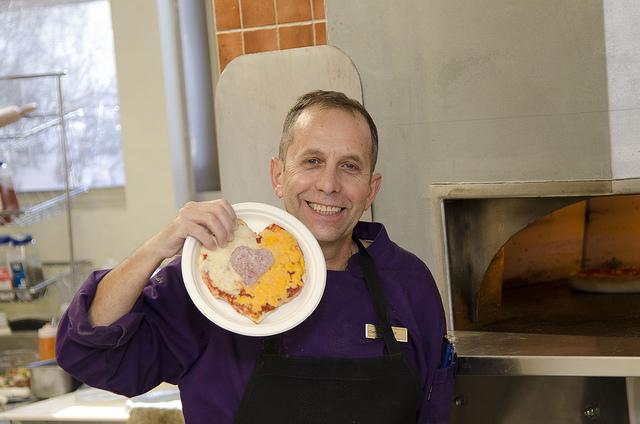What food is the heart shaped object made of?

Choices:
A) pizza
B) donut
C) spaghetti
D) burger pizza 